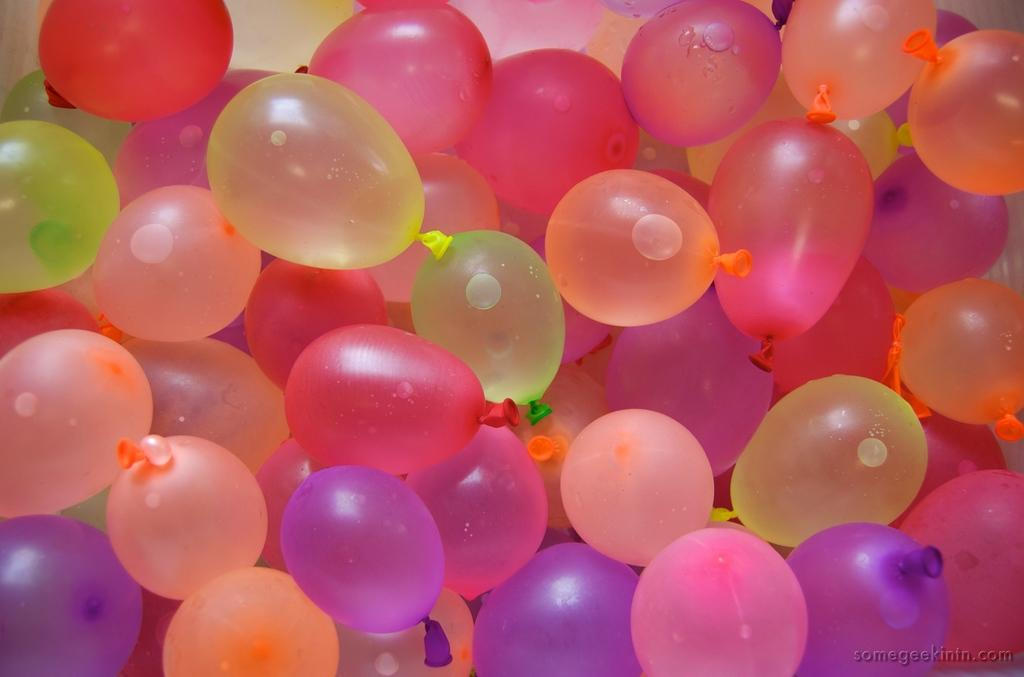What type of balloons are in the image? The balloons in the image are filled with water. What can be seen behind the balloons in the image? The background of the image is visible. What credit score is required to purchase the balloons in the image? There is no information about purchasing the balloons or any credit score requirement in the image. 